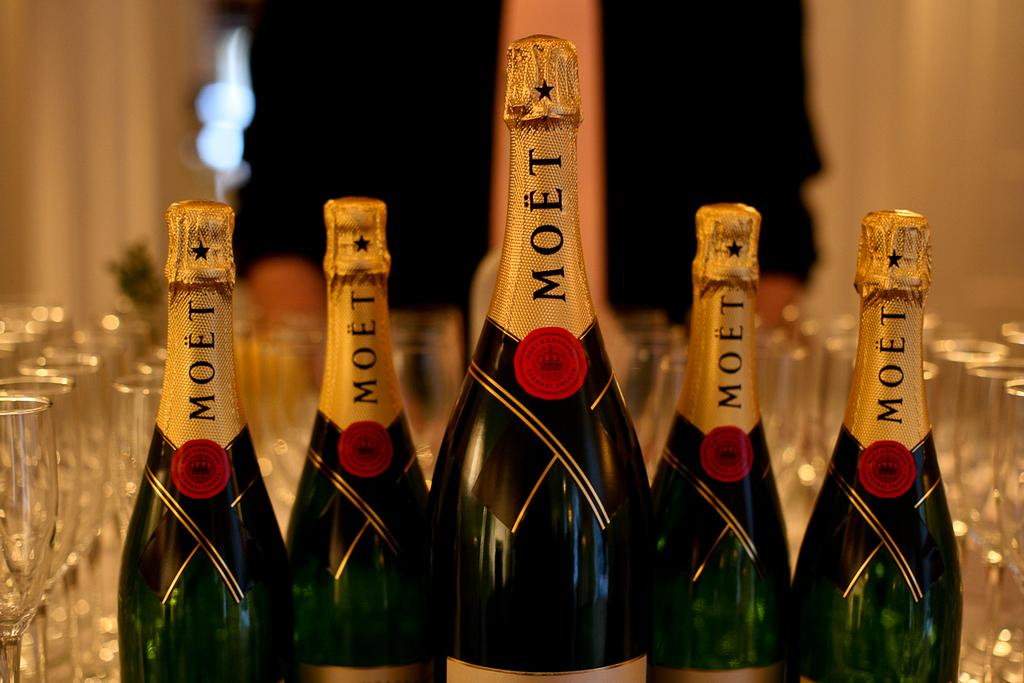<image>
Give a short and clear explanation of the subsequent image. Five bottles with golden wrapping on the top that says Moet. 